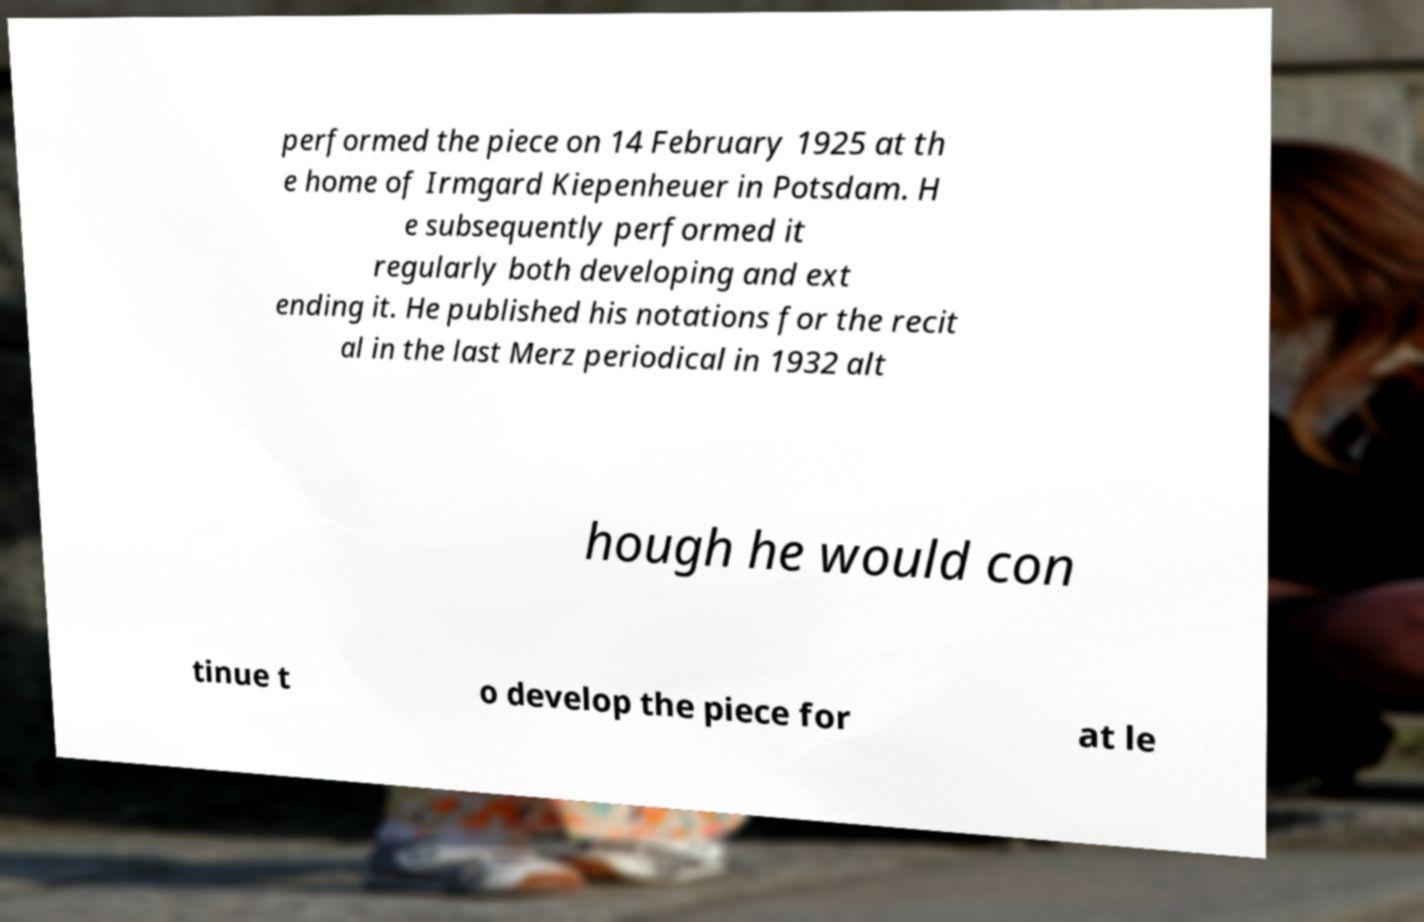Please identify and transcribe the text found in this image. performed the piece on 14 February 1925 at th e home of Irmgard Kiepenheuer in Potsdam. H e subsequently performed it regularly both developing and ext ending it. He published his notations for the recit al in the last Merz periodical in 1932 alt hough he would con tinue t o develop the piece for at le 